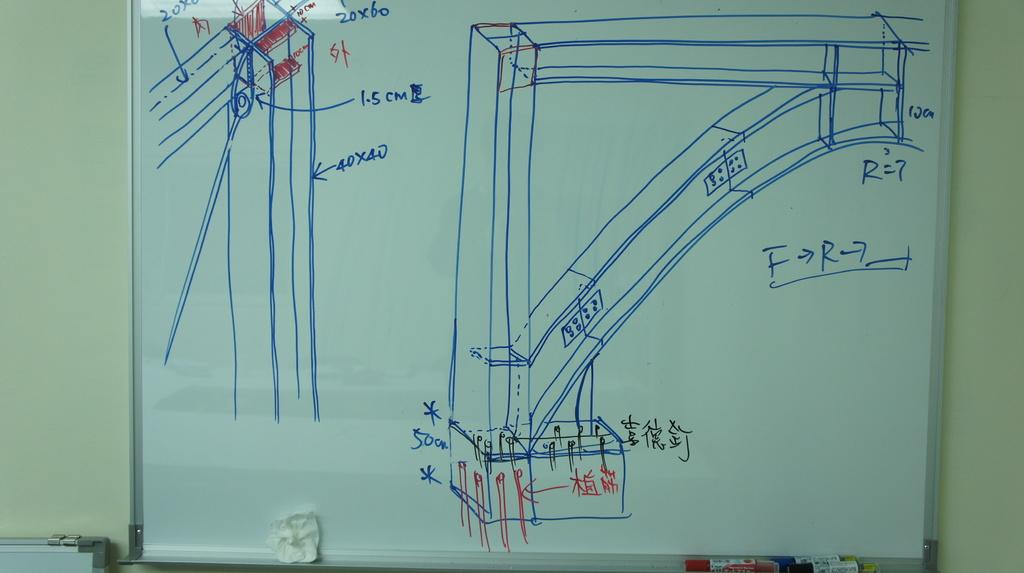Provide a one-sentence caption for the provided image. A whiteboard is covered with plans and numerical figures and measurements like 40x40. 